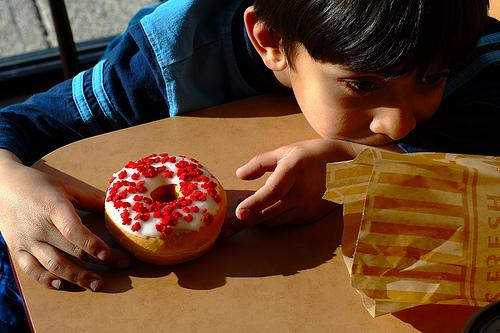Question: what color is the table?
Choices:
A. Red.
B. White.
C. Tan.
D. Blue.
Answer with the letter. Answer: C Question: who is going to eat the doughnut?
Choices:
A. A boy.
B. A construction  worker.
C. A policeman.
D. A teacher.
Answer with the letter. Answer: A 